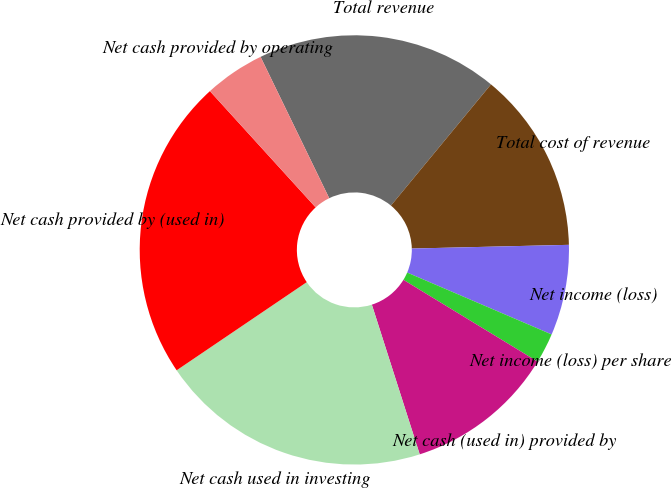Convert chart to OTSL. <chart><loc_0><loc_0><loc_500><loc_500><pie_chart><fcel>Total revenue<fcel>Total cost of revenue<fcel>Net income (loss)<fcel>Net income (loss) per share<fcel>Net cash (used in) provided by<fcel>Net cash used in investing<fcel>Net cash provided by (used in)<fcel>Net cash provided by operating<nl><fcel>18.18%<fcel>13.64%<fcel>6.82%<fcel>2.27%<fcel>11.36%<fcel>20.45%<fcel>22.73%<fcel>4.55%<nl></chart> 